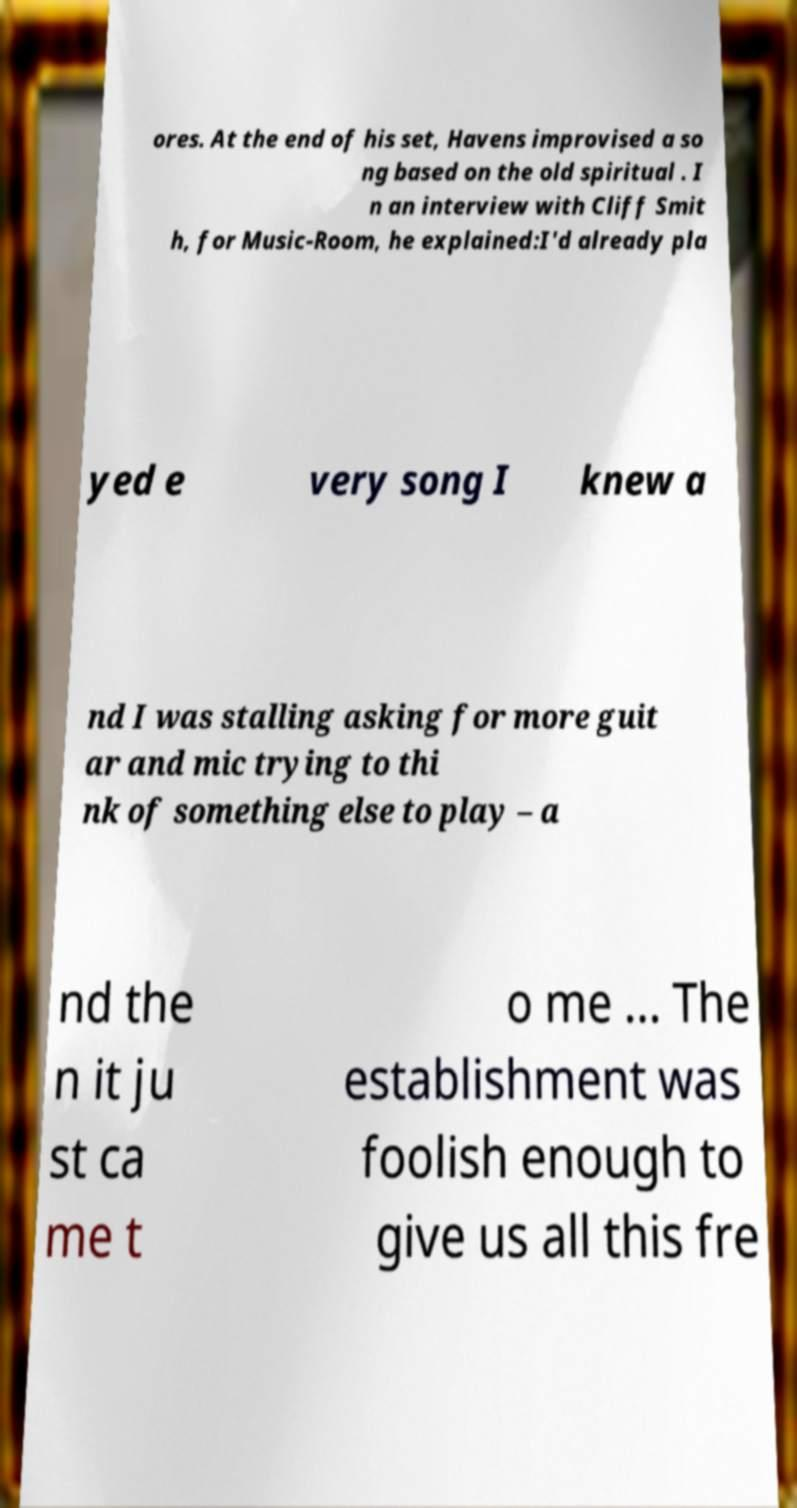Can you accurately transcribe the text from the provided image for me? ores. At the end of his set, Havens improvised a so ng based on the old spiritual . I n an interview with Cliff Smit h, for Music-Room, he explained:I'd already pla yed e very song I knew a nd I was stalling asking for more guit ar and mic trying to thi nk of something else to play – a nd the n it ju st ca me t o me ... The establishment was foolish enough to give us all this fre 